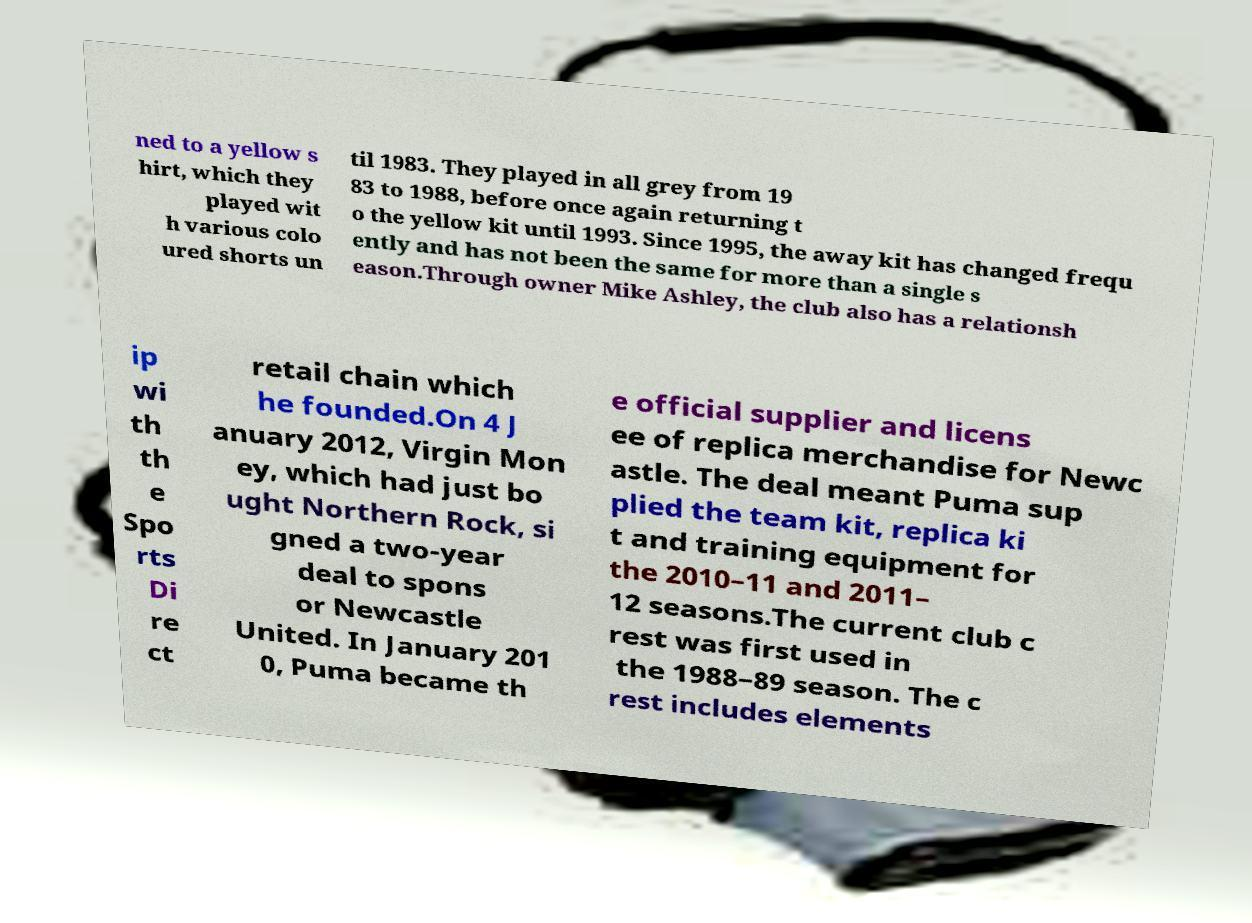Could you assist in decoding the text presented in this image and type it out clearly? ned to a yellow s hirt, which they played wit h various colo ured shorts un til 1983. They played in all grey from 19 83 to 1988, before once again returning t o the yellow kit until 1993. Since 1995, the away kit has changed frequ ently and has not been the same for more than a single s eason.Through owner Mike Ashley, the club also has a relationsh ip wi th th e Spo rts Di re ct retail chain which he founded.On 4 J anuary 2012, Virgin Mon ey, which had just bo ught Northern Rock, si gned a two-year deal to spons or Newcastle United. In January 201 0, Puma became th e official supplier and licens ee of replica merchandise for Newc astle. The deal meant Puma sup plied the team kit, replica ki t and training equipment for the 2010–11 and 2011– 12 seasons.The current club c rest was first used in the 1988–89 season. The c rest includes elements 